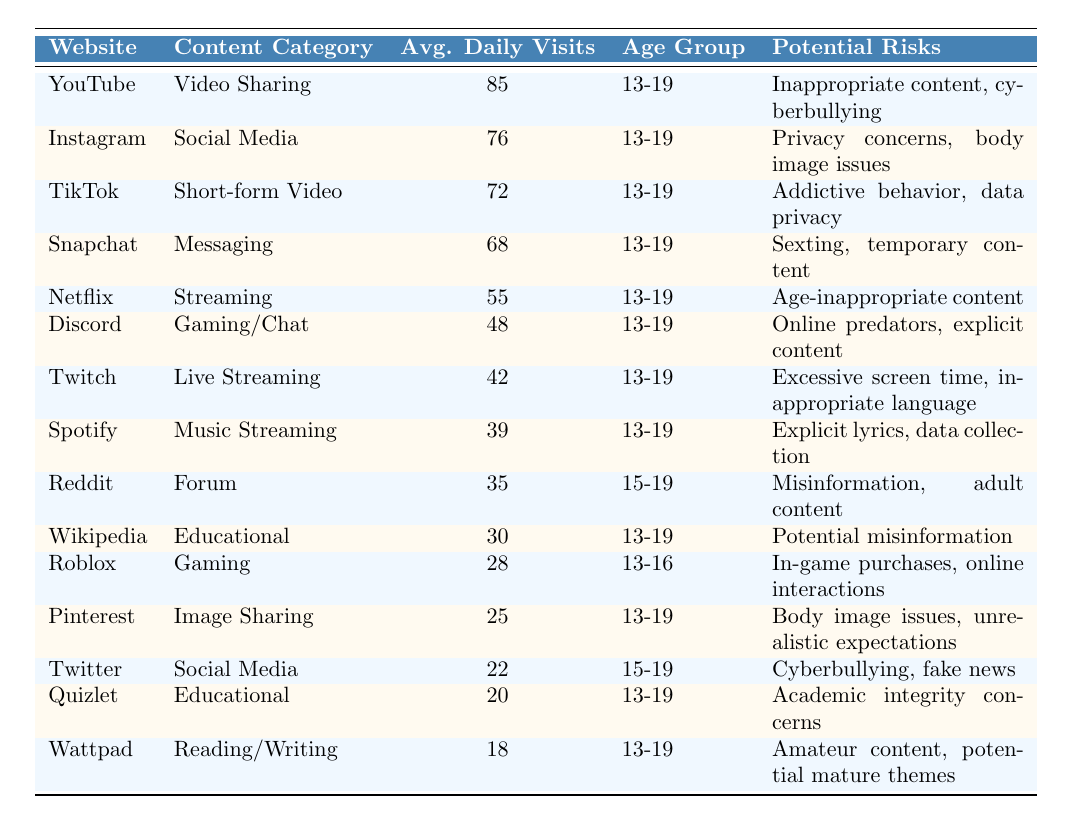What website has the highest average daily visits among teenagers? By looking at the "Average Daily Visits" column, YouTube has the highest value of 85.
Answer: YouTube Which content category does Instagram belong to? According to the "Content Category" column, Instagram is categorized under Social Media.
Answer: Social Media How many average daily visits does TikTok receive? Referring to the table, TikTok has an average of 72 daily visits.
Answer: 72 What are the potential risks associated with using Discord? The "Potential Risks" column indicates that Discord has risks such as online predators and explicit content.
Answer: Online predators, explicit content Is Netflix ranked higher in average daily visits than Snapchat? Comparing the values, Netflix has 55 daily visits while Snapchat has 68, so Netflix is ranked lower.
Answer: No How many average daily visits do the educational websites (Wikipedia and Quizlet) have combined? Adding their average visits (30 for Wikipedia and 20 for Quizlet), the total is 50 daily visits.
Answer: 50 What is the median number of average daily visits among the websites listed? The average daily visits in ascending order are: 18, 20, 22, 25, 28, 30, 35, 39, 42, 48, 55, 68, 72, 76, and 85. The middle values are 39 and 42, so the median is (39 + 42) / 2 = 40.5.
Answer: 40.5 Which website has the potential risk of body image issues? The "Potential Risks" for Instagram and Pinterest both mention body image issues.
Answer: Instagram, Pinterest How many total average daily visits do the top three websites have together? Adding the visits of YouTube (85), Instagram (76), and TikTok (72), the total is 233.
Answer: 233 Which website falls under the content category of "Music Streaming"? The table shows that Spotify is categorized under Music Streaming.
Answer: Spotify Is there any website from the table that is specifically aimed at the age group 13-16? According to the table, Roblox is the only website listed for the age group 13-16.
Answer: Yes, Roblox 